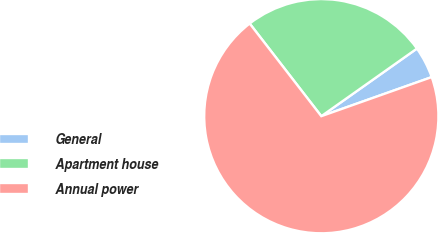Convert chart. <chart><loc_0><loc_0><loc_500><loc_500><pie_chart><fcel>General<fcel>Apartment house<fcel>Annual power<nl><fcel>4.38%<fcel>25.68%<fcel>69.94%<nl></chart> 